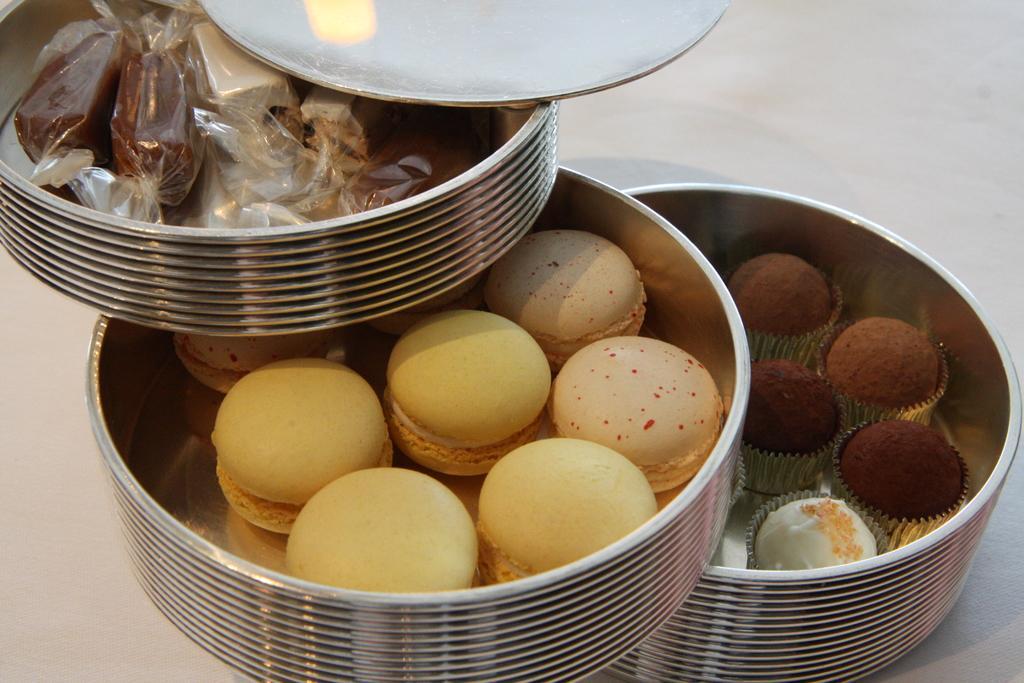Please provide a concise description of this image. In the image there are mini cakes, cookies, muffins kept in the boxes. 